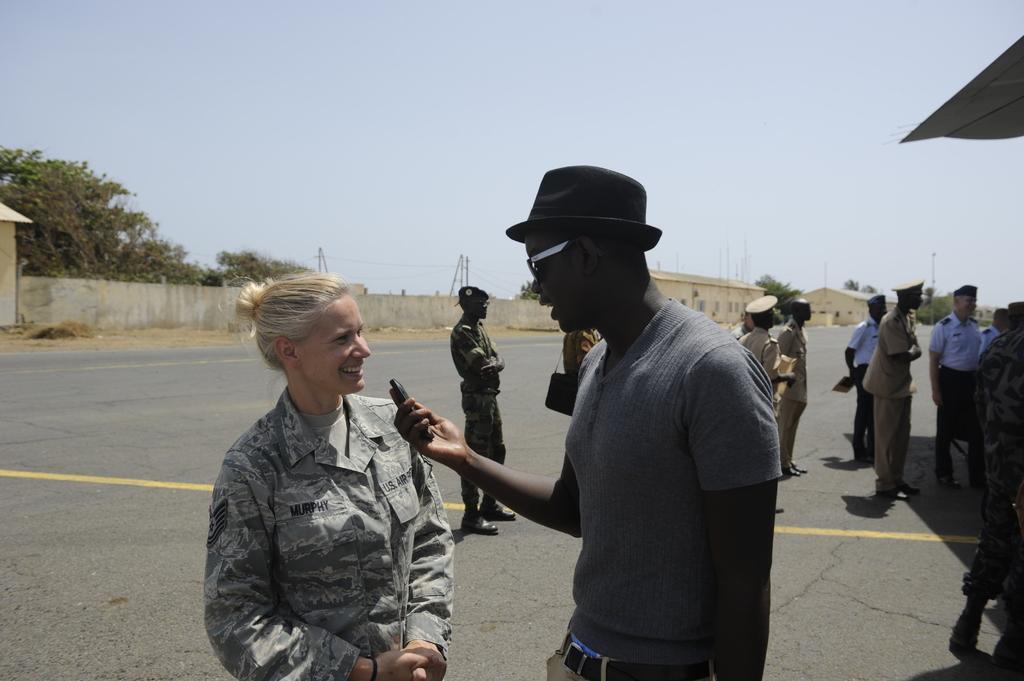Describe this image in one or two sentences. In this image I see people in which most of them are wearing uniforms and I see that this man is holding a thing in his hand and I see that he is wearing shades and a hat on his head. In the background I see the road, wall, houses, poles, trees and the sky. 